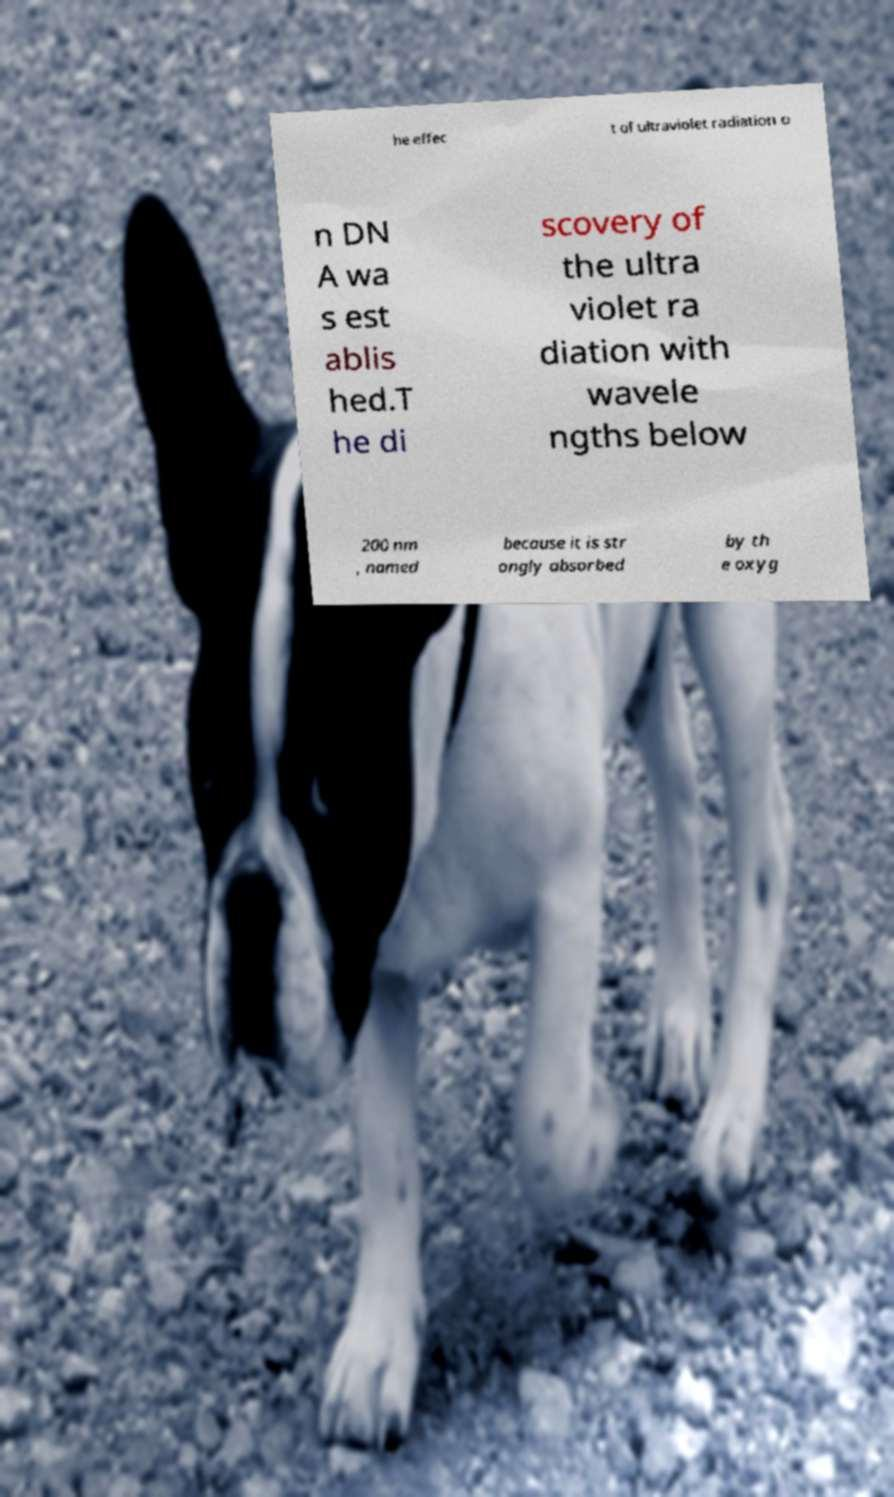Could you assist in decoding the text presented in this image and type it out clearly? he effec t of ultraviolet radiation o n DN A wa s est ablis hed.T he di scovery of the ultra violet ra diation with wavele ngths below 200 nm , named because it is str ongly absorbed by th e oxyg 